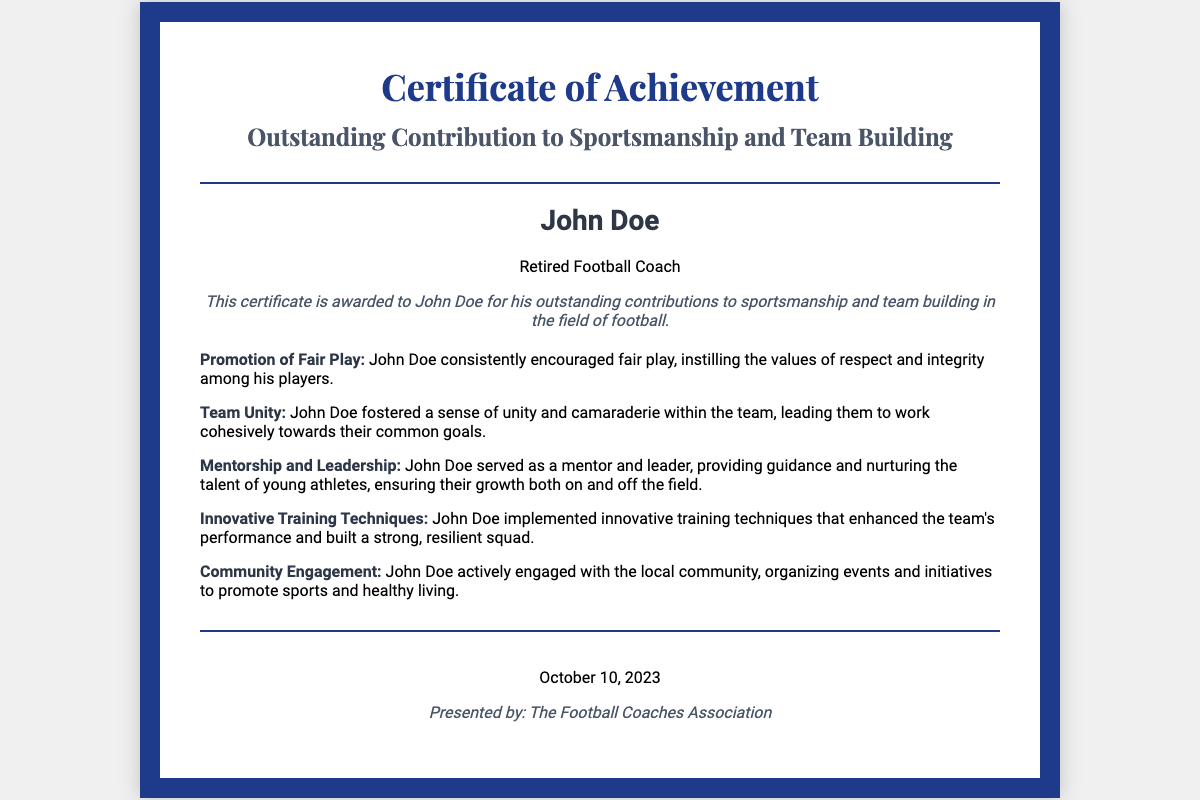What is the name of the recipient? The recipient's name is displayed prominently in the document as "John Doe."
Answer: John Doe What is the title of the certificate? The title specified at the top of the document is "Outstanding Contribution to Sportsmanship and Team Building."
Answer: Outstanding Contribution to Sportsmanship and Team Building When was the certificate awarded? The date mentioned at the bottom of the document states "October 10, 2023."
Answer: October 10, 2023 Who presented the certificate? The footer indicates that the certificate was presented by "The Football Coaches Association."
Answer: The Football Coaches Association What is one achievement mentioned in the certificate? One of the achievements listed is the "Promotion of Fair Play," illustrating John's role in encouraging integrity and respect.
Answer: Promotion of Fair Play How did John Doe contribute to community engagement? The document states that John Doe actively engaged with the local community by organizing events to promote sports and healthy living.
Answer: Organizing events What role did John Doe serve regarding young athletes? The certificate highlights that John Doe served as a mentor and leader for young athletes, nurturing their talent.
Answer: Mentor and leader What kind of training techniques did John Doe implement? The document notes that he implemented "innovative training techniques" that enhanced team performance.
Answer: Innovative training techniques What quality did John Doe foster within the team? The achievements describe that John Doe fostered "Team Unity," encouraging cohesiveness towards common goals.
Answer: Team Unity 